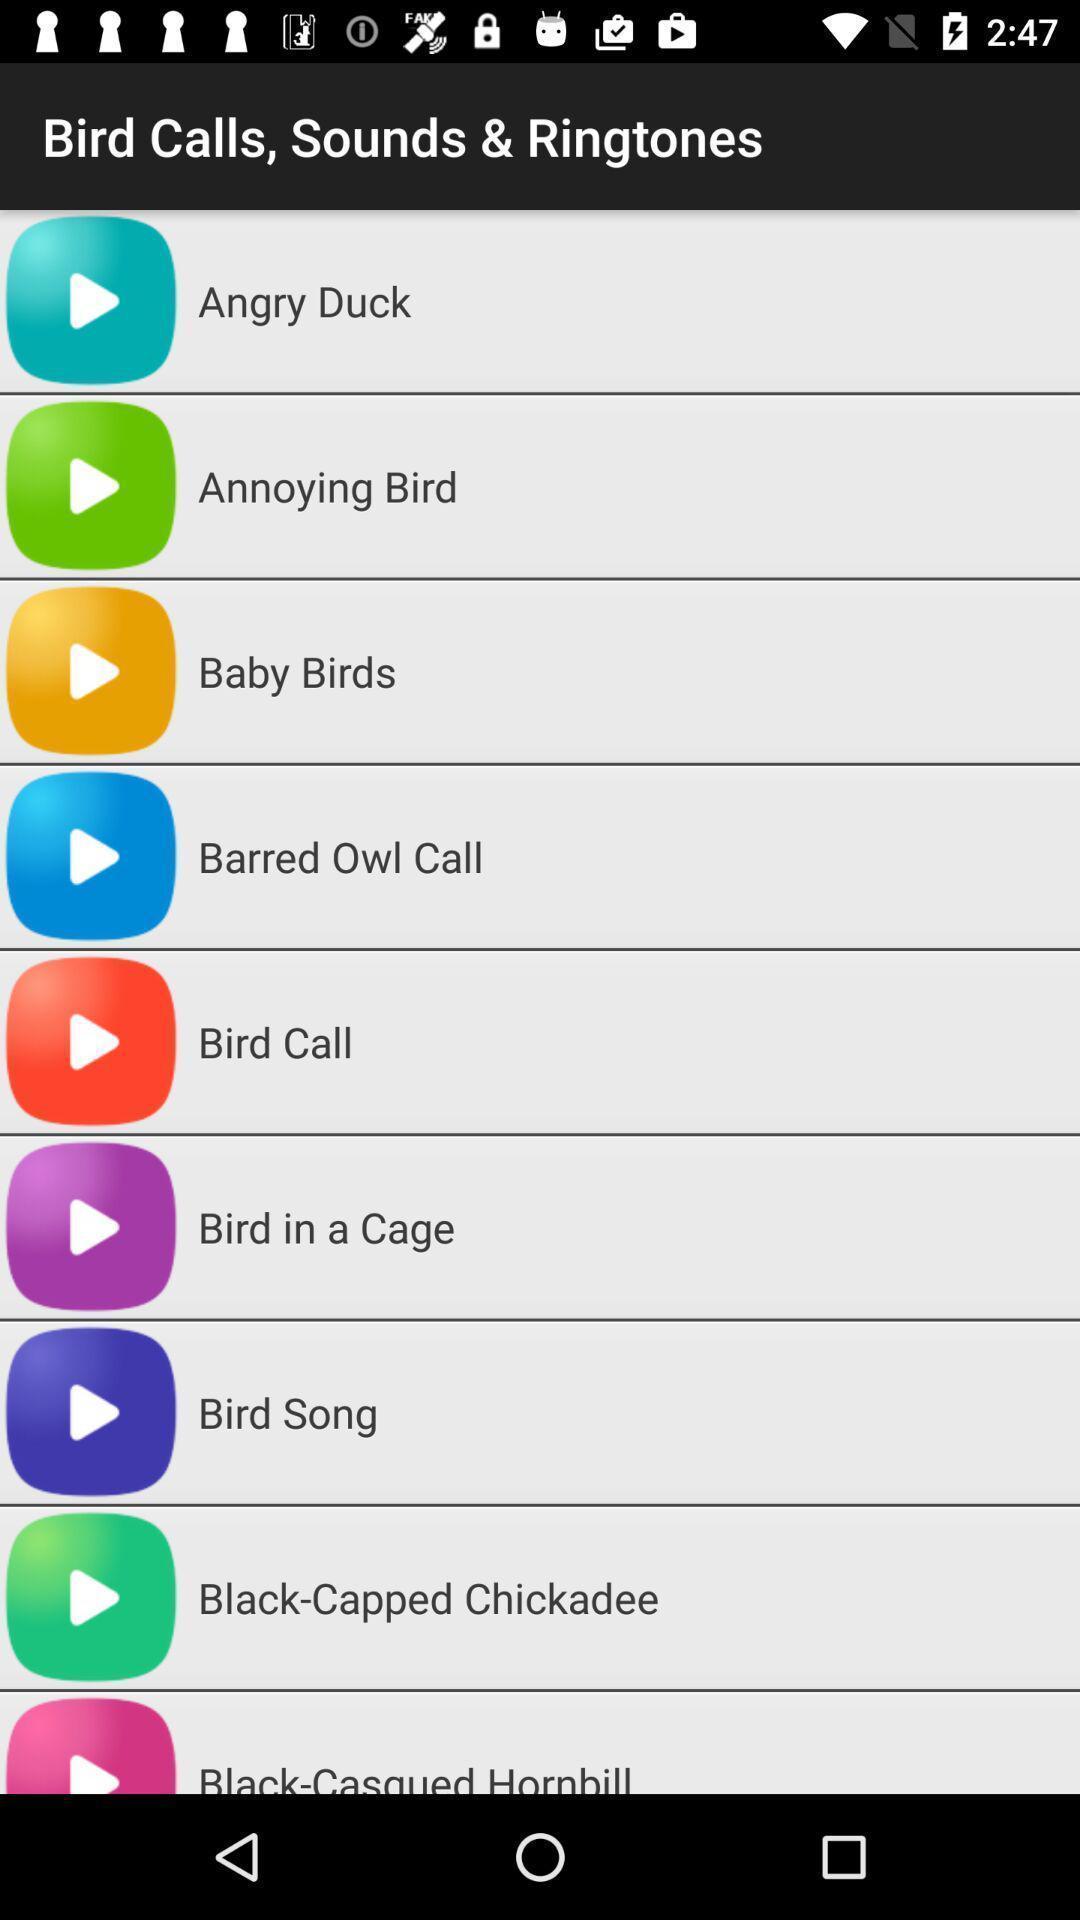Summarize the main components in this picture. Page displaying the various kinds of ringtones. 